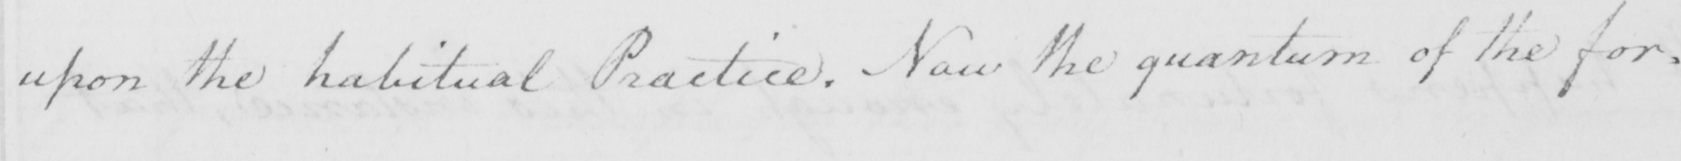Can you tell me what this handwritten text says? upon the habitual Practice . Now the quantum of the for= 